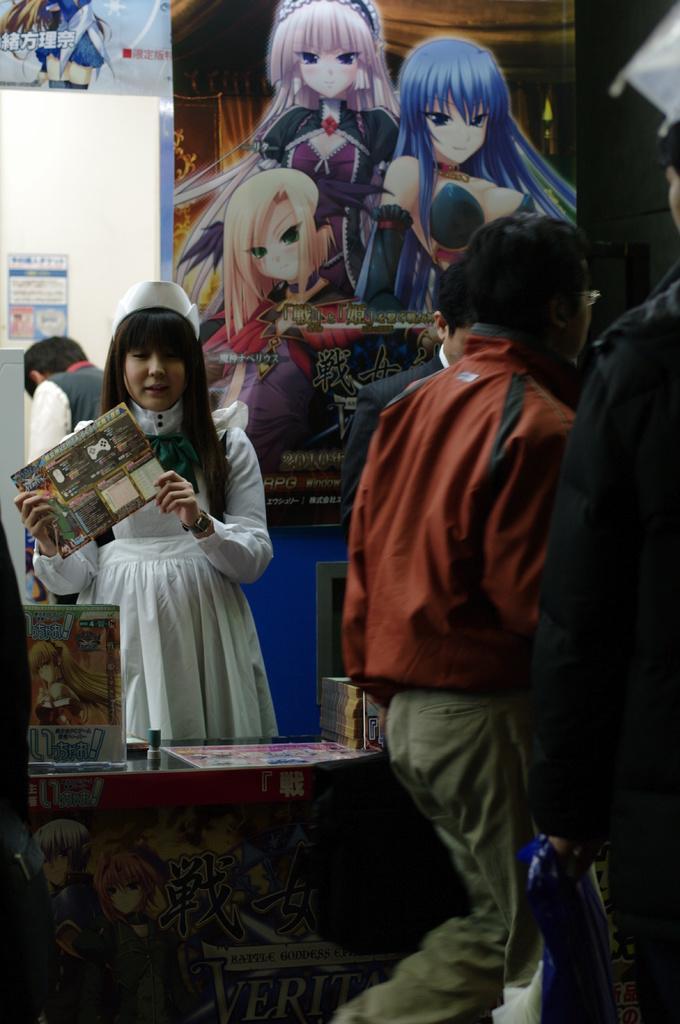Can you describe this image briefly? This picture seems to be clicked inside the room. On the right we can see the group of people. In the center we can see the table on the top of which some objects are placed and we can see a woman holding some object and standing. In the background we can see the text and the depictions of persons on the banners and we can see another person seems to be standing on the ground and we can see some other objects. 